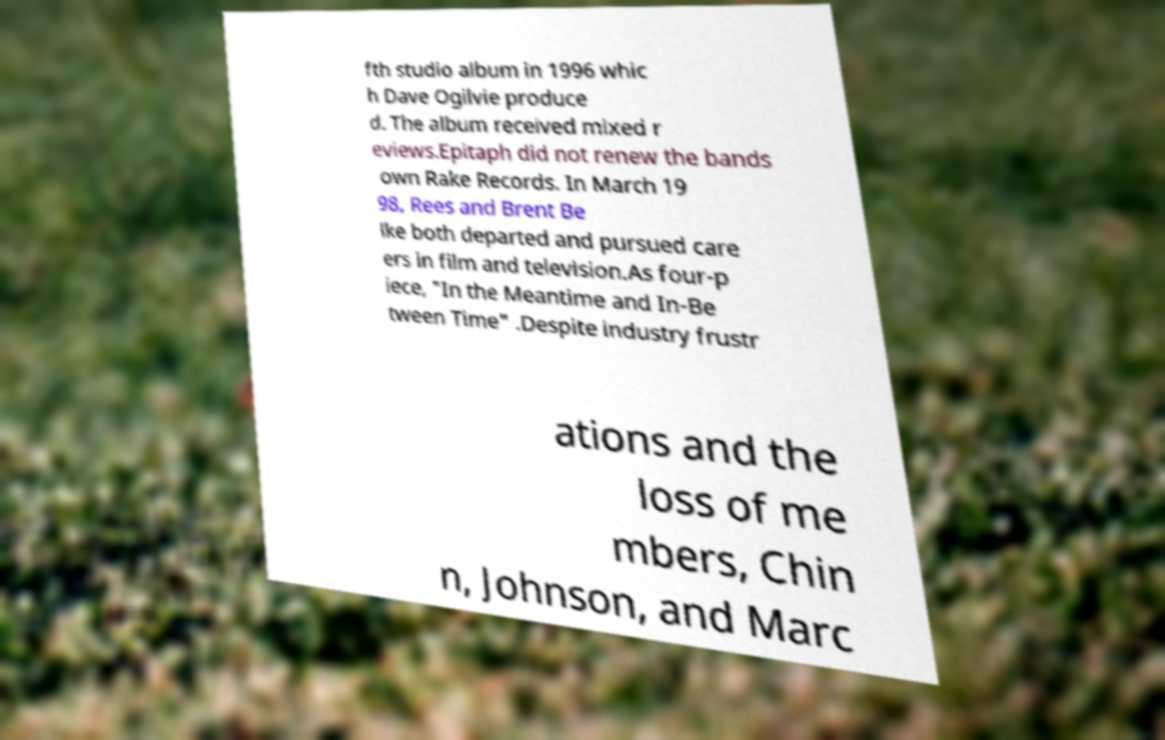Can you read and provide the text displayed in the image?This photo seems to have some interesting text. Can you extract and type it out for me? fth studio album in 1996 whic h Dave Ogilvie produce d. The album received mixed r eviews.Epitaph did not renew the bands own Rake Records. In March 19 98, Rees and Brent Be lke both departed and pursued care ers in film and television.As four-p iece, "In the Meantime and In-Be tween Time" .Despite industry frustr ations and the loss of me mbers, Chin n, Johnson, and Marc 